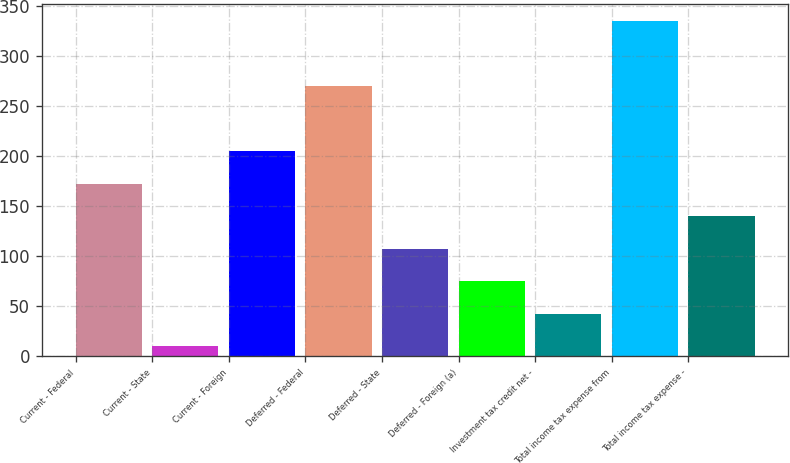Convert chart to OTSL. <chart><loc_0><loc_0><loc_500><loc_500><bar_chart><fcel>Current - Federal<fcel>Current - State<fcel>Current - Foreign<fcel>Deferred - Federal<fcel>Deferred - State<fcel>Deferred - Foreign (a)<fcel>Investment tax credit net -<fcel>Total income tax expense from<fcel>Total income tax expense -<nl><fcel>172.5<fcel>10<fcel>205<fcel>270<fcel>107.5<fcel>75<fcel>42.5<fcel>335<fcel>140<nl></chart> 